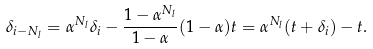<formula> <loc_0><loc_0><loc_500><loc_500>\delta _ { i - N _ { l } } = \alpha ^ { N _ { l } } \delta _ { i } - \frac { 1 - \alpha ^ { N _ { l } } } { 1 - \alpha } ( 1 - \alpha ) t = \alpha ^ { N _ { l } } ( t + \delta _ { i } ) - t .</formula> 